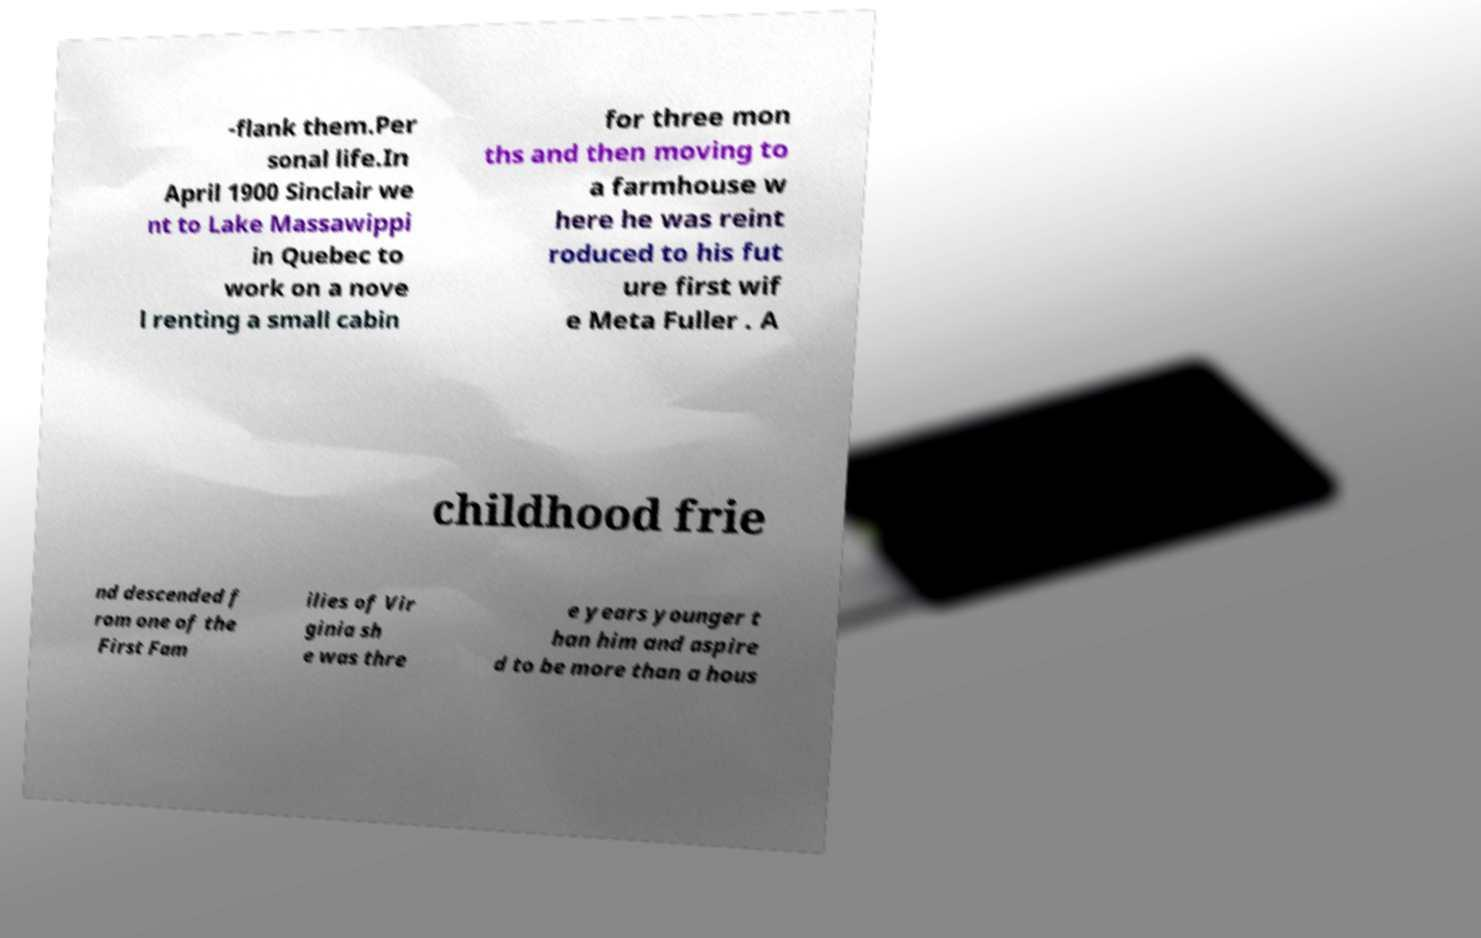Can you accurately transcribe the text from the provided image for me? -flank them.Per sonal life.In April 1900 Sinclair we nt to Lake Massawippi in Quebec to work on a nove l renting a small cabin for three mon ths and then moving to a farmhouse w here he was reint roduced to his fut ure first wif e Meta Fuller . A childhood frie nd descended f rom one of the First Fam ilies of Vir ginia sh e was thre e years younger t han him and aspire d to be more than a hous 